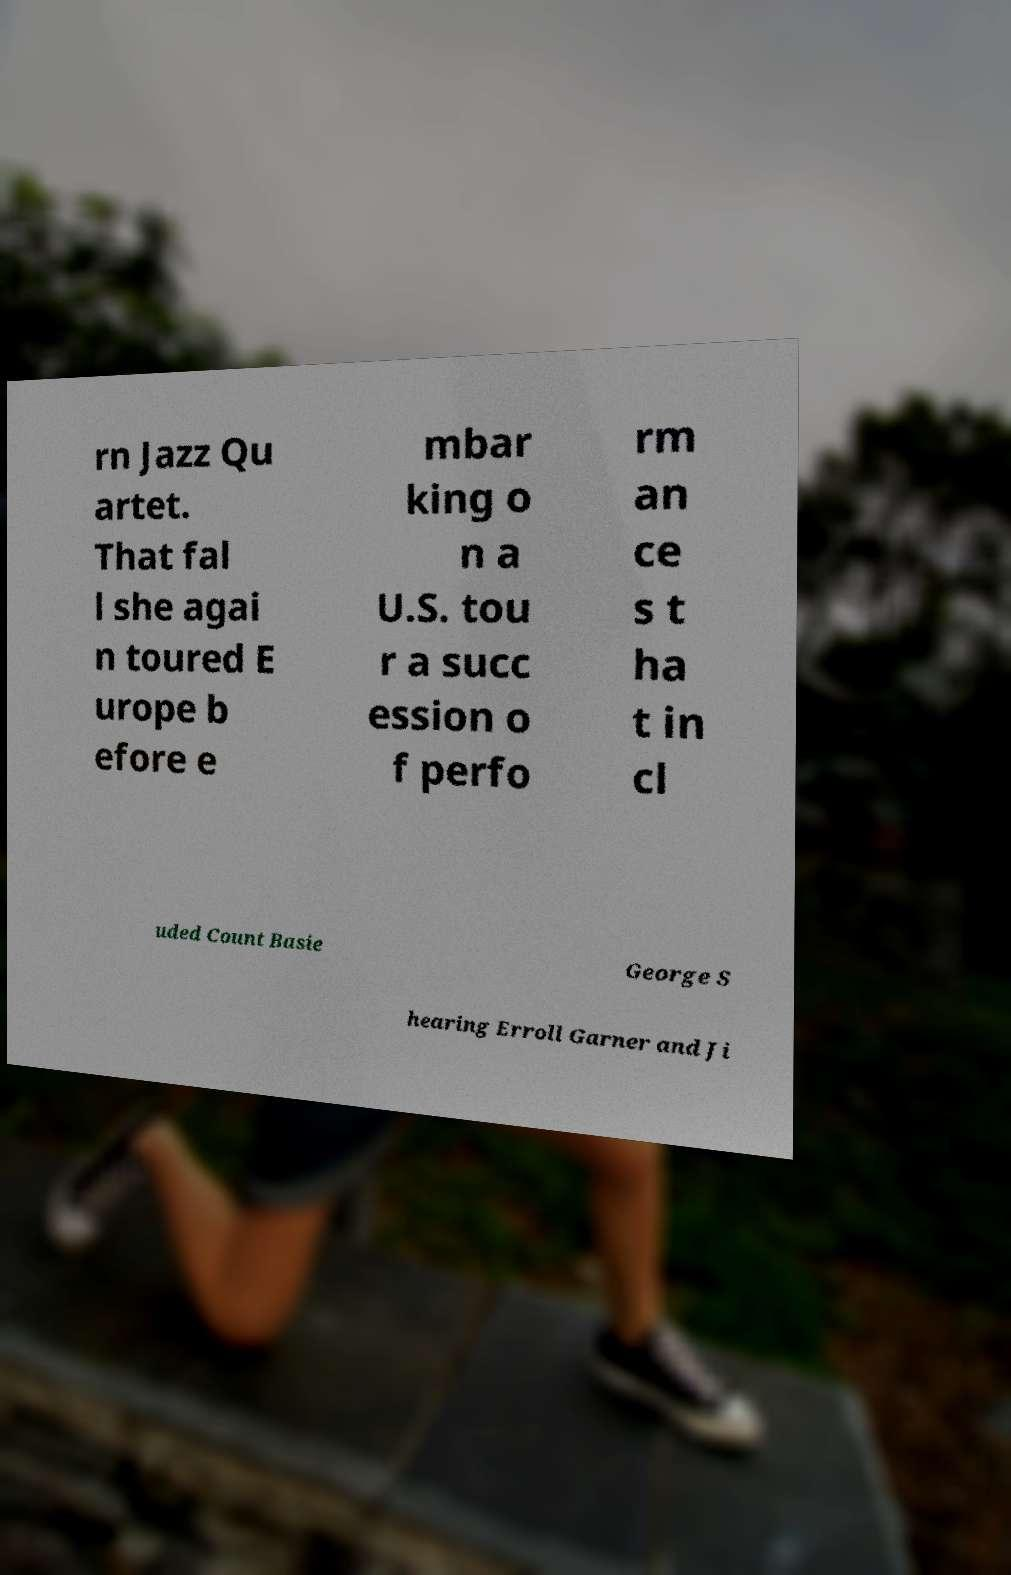There's text embedded in this image that I need extracted. Can you transcribe it verbatim? rn Jazz Qu artet. That fal l she agai n toured E urope b efore e mbar king o n a U.S. tou r a succ ession o f perfo rm an ce s t ha t in cl uded Count Basie George S hearing Erroll Garner and Ji 